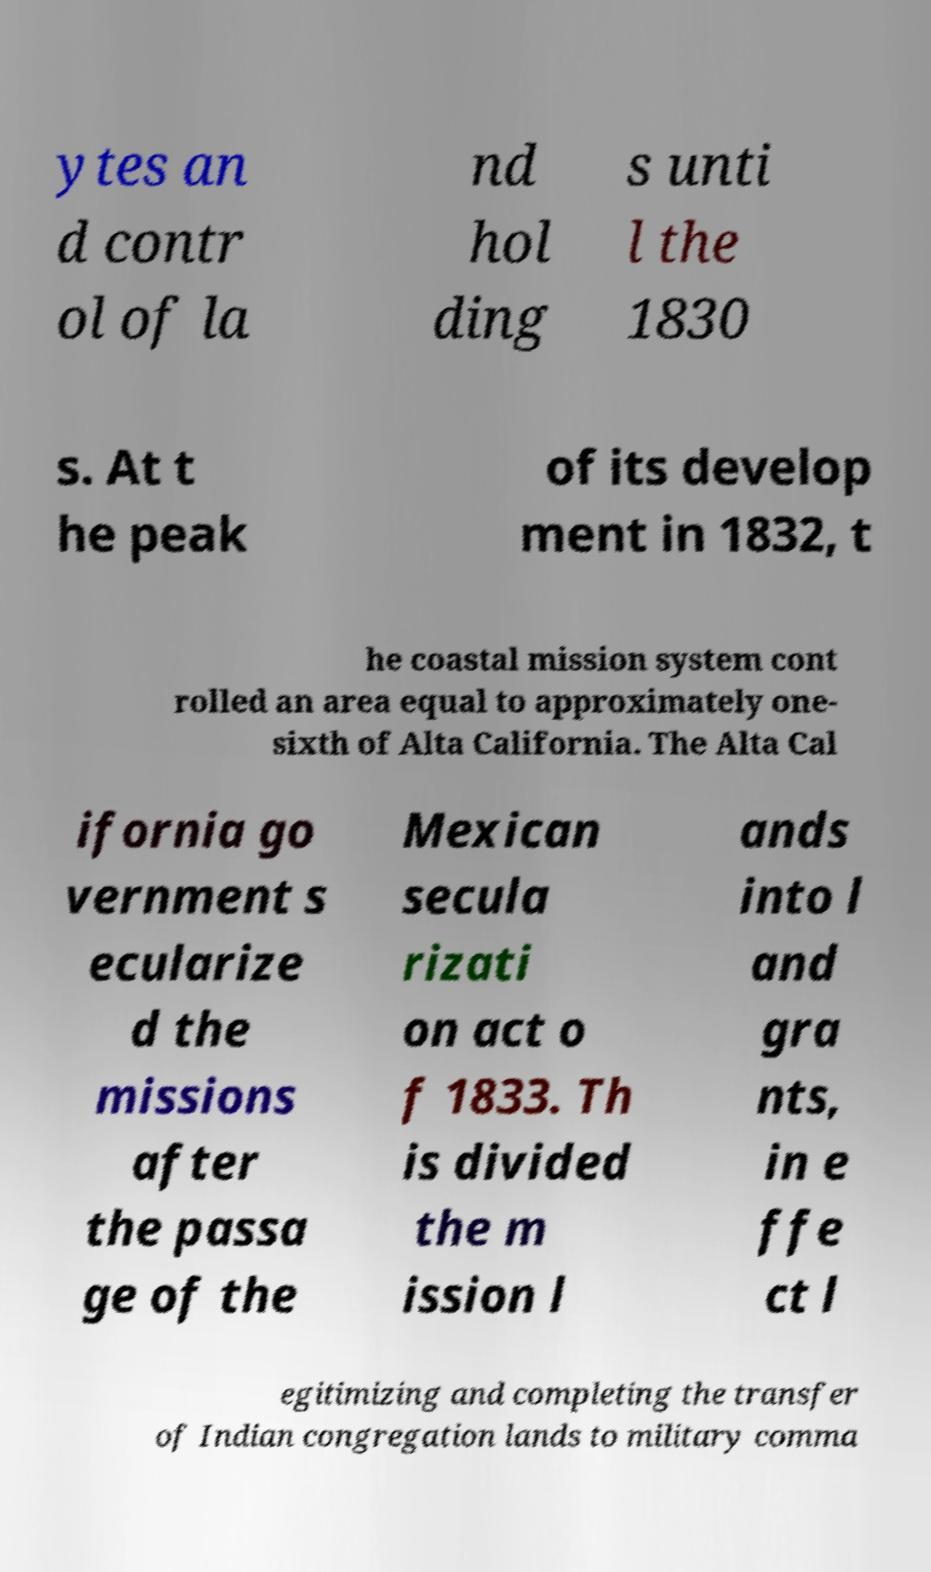There's text embedded in this image that I need extracted. Can you transcribe it verbatim? ytes an d contr ol of la nd hol ding s unti l the 1830 s. At t he peak of its develop ment in 1832, t he coastal mission system cont rolled an area equal to approximately one- sixth of Alta California. The Alta Cal ifornia go vernment s ecularize d the missions after the passa ge of the Mexican secula rizati on act o f 1833. Th is divided the m ission l ands into l and gra nts, in e ffe ct l egitimizing and completing the transfer of Indian congregation lands to military comma 